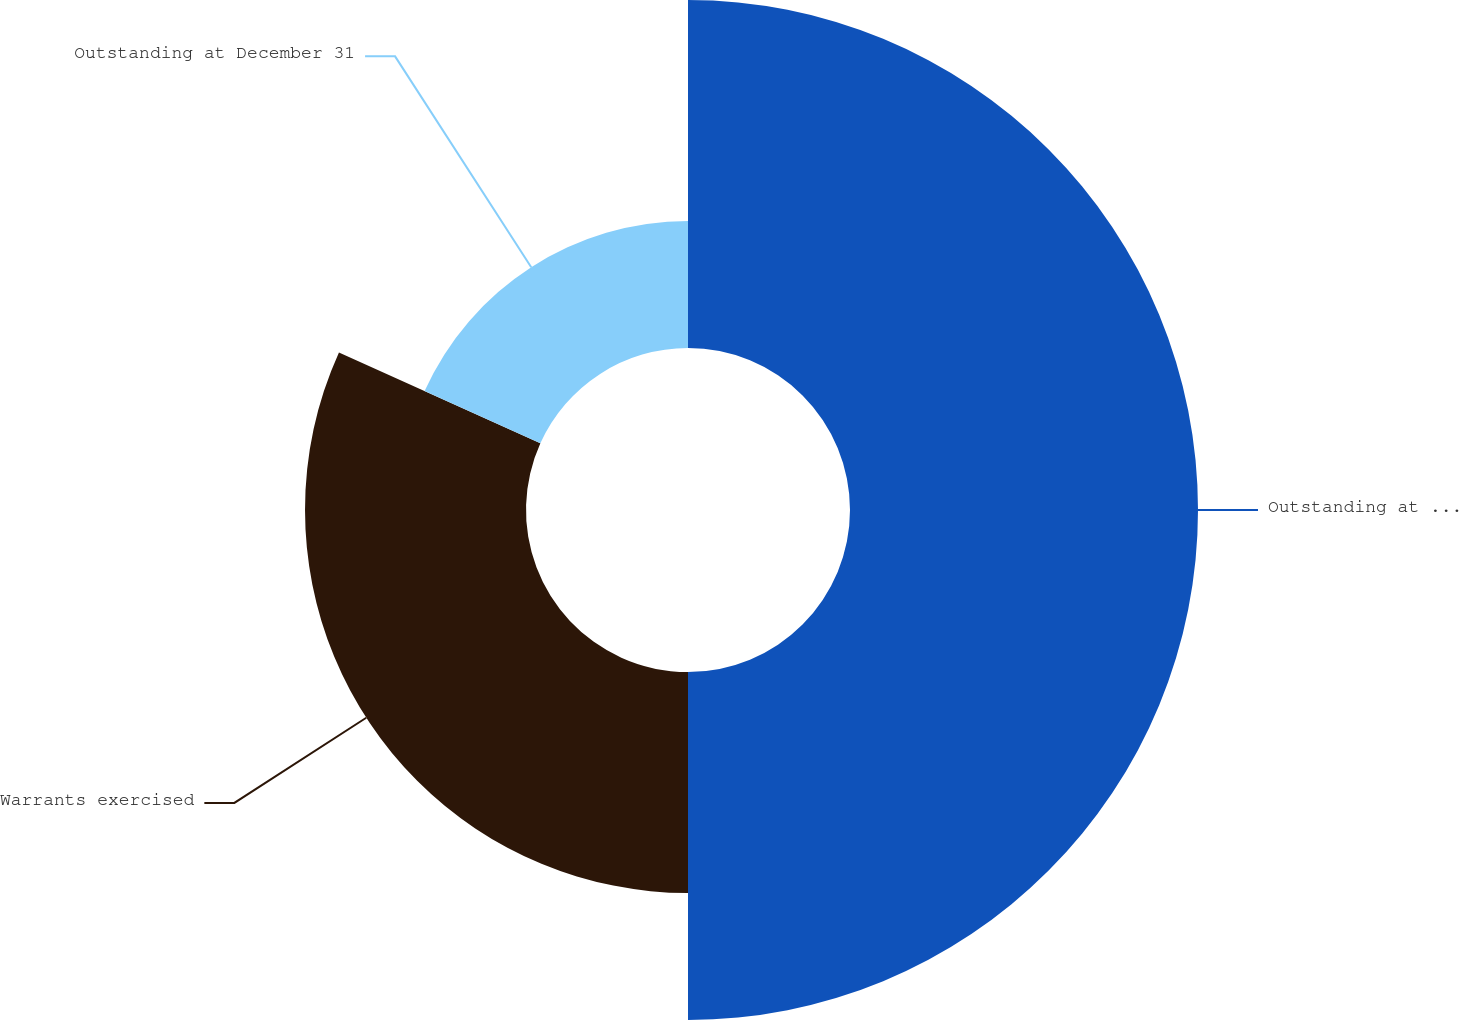<chart> <loc_0><loc_0><loc_500><loc_500><pie_chart><fcel>Outstanding at January 1<fcel>Warrants exercised<fcel>Outstanding at December 31<nl><fcel>50.0%<fcel>31.75%<fcel>18.25%<nl></chart> 